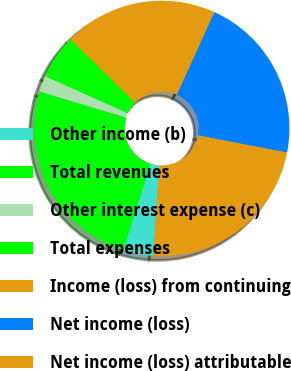<chart> <loc_0><loc_0><loc_500><loc_500><pie_chart><fcel>Other income (b)<fcel>Total revenues<fcel>Other interest expense (c)<fcel>Total expenses<fcel>Income (loss) from continuing<fcel>Net income (loss)<fcel>Net income (loss) attributable<nl><fcel>3.82%<fcel>24.8%<fcel>2.04%<fcel>5.59%<fcel>19.47%<fcel>21.25%<fcel>23.02%<nl></chart> 